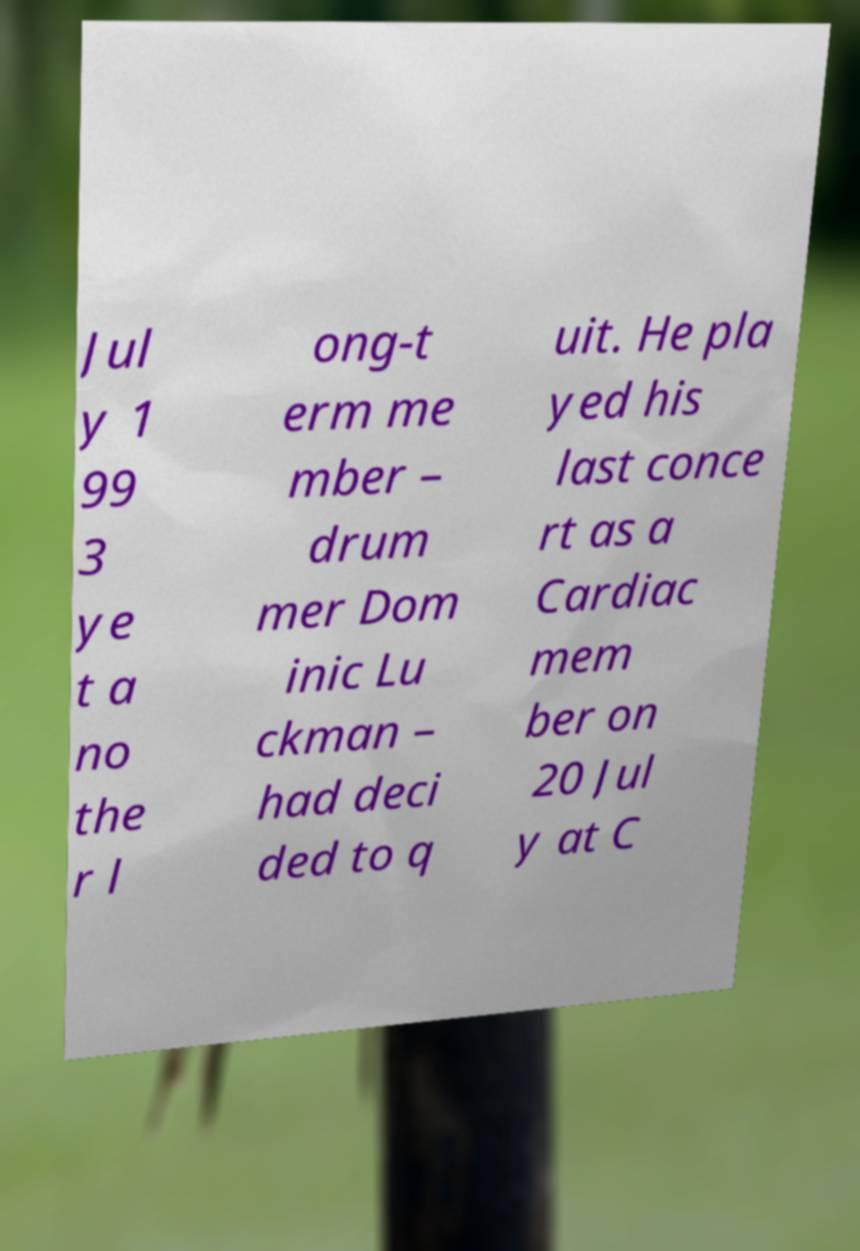I need the written content from this picture converted into text. Can you do that? Jul y 1 99 3 ye t a no the r l ong-t erm me mber – drum mer Dom inic Lu ckman – had deci ded to q uit. He pla yed his last conce rt as a Cardiac mem ber on 20 Jul y at C 